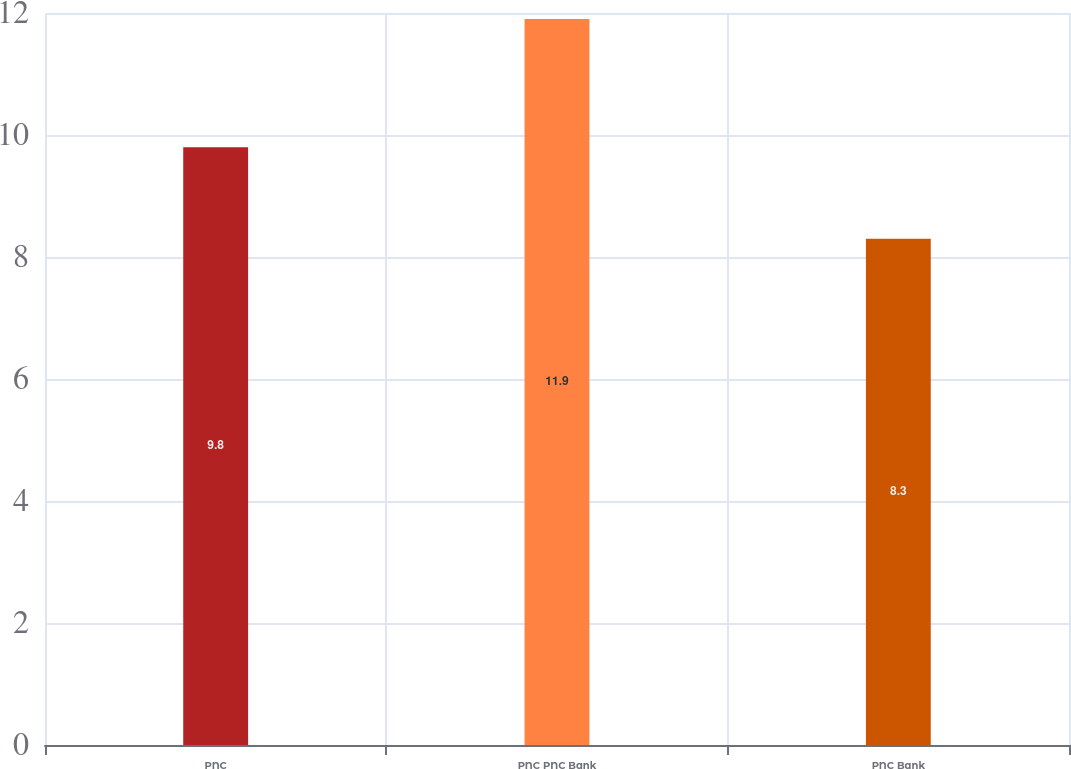Convert chart. <chart><loc_0><loc_0><loc_500><loc_500><bar_chart><fcel>PNC<fcel>PNC PNC Bank<fcel>PNC Bank<nl><fcel>9.8<fcel>11.9<fcel>8.3<nl></chart> 